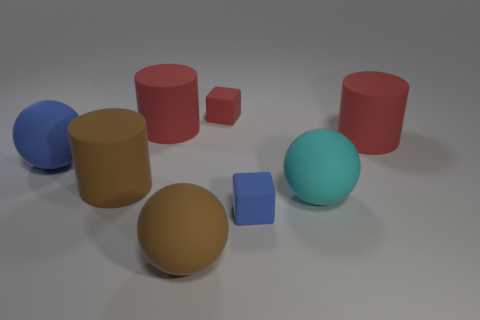Add 1 brown rubber cylinders. How many objects exist? 9 Subtract all balls. How many objects are left? 5 Subtract all big things. Subtract all red metal objects. How many objects are left? 2 Add 7 brown spheres. How many brown spheres are left? 8 Add 6 rubber blocks. How many rubber blocks exist? 8 Subtract 1 blue blocks. How many objects are left? 7 